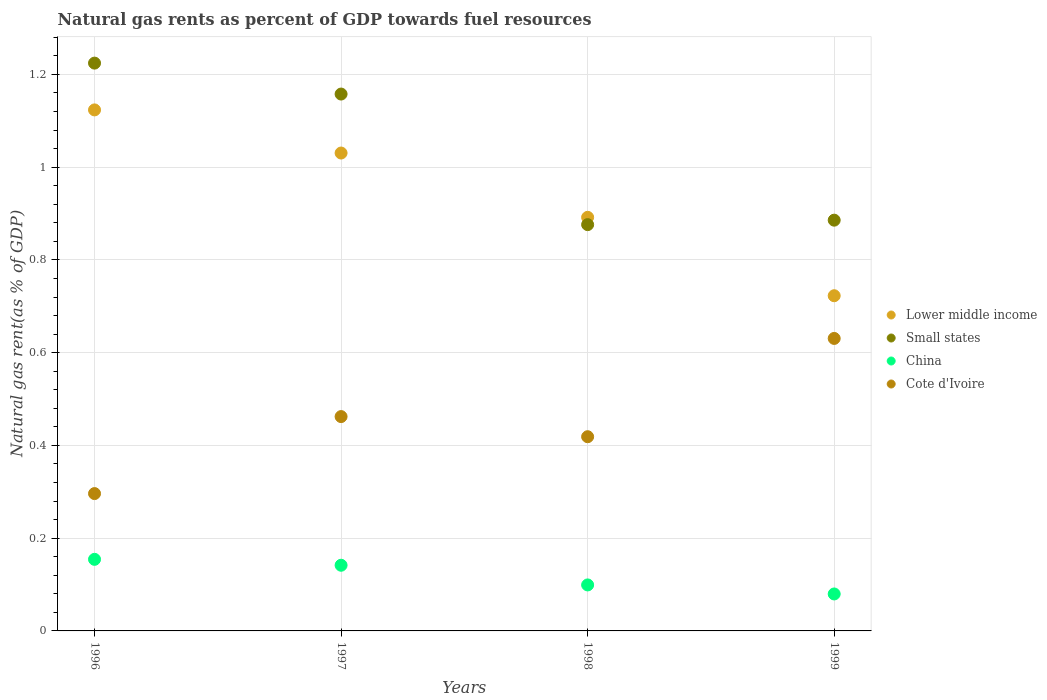Is the number of dotlines equal to the number of legend labels?
Your answer should be compact. Yes. What is the natural gas rent in Cote d'Ivoire in 1998?
Your answer should be very brief. 0.42. Across all years, what is the maximum natural gas rent in Small states?
Make the answer very short. 1.22. Across all years, what is the minimum natural gas rent in China?
Provide a succinct answer. 0.08. In which year was the natural gas rent in Lower middle income minimum?
Your response must be concise. 1999. What is the total natural gas rent in China in the graph?
Make the answer very short. 0.47. What is the difference between the natural gas rent in China in 1996 and that in 1999?
Offer a very short reply. 0.07. What is the difference between the natural gas rent in China in 1997 and the natural gas rent in Small states in 1999?
Offer a very short reply. -0.74. What is the average natural gas rent in Lower middle income per year?
Ensure brevity in your answer.  0.94. In the year 1999, what is the difference between the natural gas rent in Cote d'Ivoire and natural gas rent in Lower middle income?
Give a very brief answer. -0.09. In how many years, is the natural gas rent in Cote d'Ivoire greater than 0.7600000000000001 %?
Give a very brief answer. 0. What is the ratio of the natural gas rent in Small states in 1996 to that in 1997?
Your response must be concise. 1.06. Is the natural gas rent in Small states in 1997 less than that in 1999?
Keep it short and to the point. No. Is the difference between the natural gas rent in Cote d'Ivoire in 1996 and 1997 greater than the difference between the natural gas rent in Lower middle income in 1996 and 1997?
Provide a short and direct response. No. What is the difference between the highest and the second highest natural gas rent in China?
Keep it short and to the point. 0.01. What is the difference between the highest and the lowest natural gas rent in Cote d'Ivoire?
Ensure brevity in your answer.  0.33. In how many years, is the natural gas rent in Lower middle income greater than the average natural gas rent in Lower middle income taken over all years?
Provide a succinct answer. 2. Is the sum of the natural gas rent in Cote d'Ivoire in 1996 and 1999 greater than the maximum natural gas rent in Lower middle income across all years?
Provide a succinct answer. No. Is it the case that in every year, the sum of the natural gas rent in Lower middle income and natural gas rent in Small states  is greater than the sum of natural gas rent in Cote d'Ivoire and natural gas rent in China?
Give a very brief answer. No. Is it the case that in every year, the sum of the natural gas rent in Lower middle income and natural gas rent in Cote d'Ivoire  is greater than the natural gas rent in China?
Your answer should be compact. Yes. Does the natural gas rent in Lower middle income monotonically increase over the years?
Ensure brevity in your answer.  No. Is the natural gas rent in China strictly greater than the natural gas rent in Small states over the years?
Give a very brief answer. No. Is the natural gas rent in Small states strictly less than the natural gas rent in Cote d'Ivoire over the years?
Your answer should be very brief. No. How many dotlines are there?
Your answer should be very brief. 4. How many years are there in the graph?
Provide a short and direct response. 4. What is the difference between two consecutive major ticks on the Y-axis?
Ensure brevity in your answer.  0.2. Does the graph contain any zero values?
Provide a succinct answer. No. How many legend labels are there?
Your response must be concise. 4. What is the title of the graph?
Keep it short and to the point. Natural gas rents as percent of GDP towards fuel resources. Does "Brunei Darussalam" appear as one of the legend labels in the graph?
Your response must be concise. No. What is the label or title of the Y-axis?
Provide a succinct answer. Natural gas rent(as % of GDP). What is the Natural gas rent(as % of GDP) of Lower middle income in 1996?
Offer a very short reply. 1.12. What is the Natural gas rent(as % of GDP) of Small states in 1996?
Make the answer very short. 1.22. What is the Natural gas rent(as % of GDP) of China in 1996?
Ensure brevity in your answer.  0.15. What is the Natural gas rent(as % of GDP) of Cote d'Ivoire in 1996?
Provide a short and direct response. 0.3. What is the Natural gas rent(as % of GDP) of Lower middle income in 1997?
Your answer should be very brief. 1.03. What is the Natural gas rent(as % of GDP) in Small states in 1997?
Your answer should be very brief. 1.16. What is the Natural gas rent(as % of GDP) of China in 1997?
Offer a very short reply. 0.14. What is the Natural gas rent(as % of GDP) of Cote d'Ivoire in 1997?
Your response must be concise. 0.46. What is the Natural gas rent(as % of GDP) in Lower middle income in 1998?
Your answer should be very brief. 0.89. What is the Natural gas rent(as % of GDP) of Small states in 1998?
Provide a short and direct response. 0.88. What is the Natural gas rent(as % of GDP) of China in 1998?
Give a very brief answer. 0.1. What is the Natural gas rent(as % of GDP) in Cote d'Ivoire in 1998?
Your response must be concise. 0.42. What is the Natural gas rent(as % of GDP) in Lower middle income in 1999?
Offer a very short reply. 0.72. What is the Natural gas rent(as % of GDP) of Small states in 1999?
Provide a succinct answer. 0.89. What is the Natural gas rent(as % of GDP) of China in 1999?
Your response must be concise. 0.08. What is the Natural gas rent(as % of GDP) of Cote d'Ivoire in 1999?
Offer a terse response. 0.63. Across all years, what is the maximum Natural gas rent(as % of GDP) of Lower middle income?
Your answer should be very brief. 1.12. Across all years, what is the maximum Natural gas rent(as % of GDP) in Small states?
Provide a succinct answer. 1.22. Across all years, what is the maximum Natural gas rent(as % of GDP) in China?
Your answer should be compact. 0.15. Across all years, what is the maximum Natural gas rent(as % of GDP) of Cote d'Ivoire?
Ensure brevity in your answer.  0.63. Across all years, what is the minimum Natural gas rent(as % of GDP) in Lower middle income?
Your answer should be compact. 0.72. Across all years, what is the minimum Natural gas rent(as % of GDP) of Small states?
Make the answer very short. 0.88. Across all years, what is the minimum Natural gas rent(as % of GDP) of China?
Offer a very short reply. 0.08. Across all years, what is the minimum Natural gas rent(as % of GDP) in Cote d'Ivoire?
Keep it short and to the point. 0.3. What is the total Natural gas rent(as % of GDP) of Lower middle income in the graph?
Make the answer very short. 3.77. What is the total Natural gas rent(as % of GDP) in Small states in the graph?
Give a very brief answer. 4.14. What is the total Natural gas rent(as % of GDP) of China in the graph?
Offer a terse response. 0.47. What is the total Natural gas rent(as % of GDP) in Cote d'Ivoire in the graph?
Give a very brief answer. 1.81. What is the difference between the Natural gas rent(as % of GDP) of Lower middle income in 1996 and that in 1997?
Offer a terse response. 0.09. What is the difference between the Natural gas rent(as % of GDP) in Small states in 1996 and that in 1997?
Your answer should be very brief. 0.07. What is the difference between the Natural gas rent(as % of GDP) of China in 1996 and that in 1997?
Give a very brief answer. 0.01. What is the difference between the Natural gas rent(as % of GDP) of Cote d'Ivoire in 1996 and that in 1997?
Give a very brief answer. -0.17. What is the difference between the Natural gas rent(as % of GDP) of Lower middle income in 1996 and that in 1998?
Provide a short and direct response. 0.23. What is the difference between the Natural gas rent(as % of GDP) of Small states in 1996 and that in 1998?
Make the answer very short. 0.35. What is the difference between the Natural gas rent(as % of GDP) of China in 1996 and that in 1998?
Offer a terse response. 0.06. What is the difference between the Natural gas rent(as % of GDP) of Cote d'Ivoire in 1996 and that in 1998?
Make the answer very short. -0.12. What is the difference between the Natural gas rent(as % of GDP) of Lower middle income in 1996 and that in 1999?
Provide a short and direct response. 0.4. What is the difference between the Natural gas rent(as % of GDP) of Small states in 1996 and that in 1999?
Offer a very short reply. 0.34. What is the difference between the Natural gas rent(as % of GDP) of China in 1996 and that in 1999?
Ensure brevity in your answer.  0.07. What is the difference between the Natural gas rent(as % of GDP) of Cote d'Ivoire in 1996 and that in 1999?
Ensure brevity in your answer.  -0.33. What is the difference between the Natural gas rent(as % of GDP) of Lower middle income in 1997 and that in 1998?
Ensure brevity in your answer.  0.14. What is the difference between the Natural gas rent(as % of GDP) of Small states in 1997 and that in 1998?
Keep it short and to the point. 0.28. What is the difference between the Natural gas rent(as % of GDP) in China in 1997 and that in 1998?
Provide a short and direct response. 0.04. What is the difference between the Natural gas rent(as % of GDP) in Cote d'Ivoire in 1997 and that in 1998?
Your answer should be very brief. 0.04. What is the difference between the Natural gas rent(as % of GDP) in Lower middle income in 1997 and that in 1999?
Give a very brief answer. 0.31. What is the difference between the Natural gas rent(as % of GDP) of Small states in 1997 and that in 1999?
Ensure brevity in your answer.  0.27. What is the difference between the Natural gas rent(as % of GDP) in China in 1997 and that in 1999?
Your answer should be compact. 0.06. What is the difference between the Natural gas rent(as % of GDP) of Cote d'Ivoire in 1997 and that in 1999?
Your answer should be very brief. -0.17. What is the difference between the Natural gas rent(as % of GDP) in Lower middle income in 1998 and that in 1999?
Your response must be concise. 0.17. What is the difference between the Natural gas rent(as % of GDP) of Small states in 1998 and that in 1999?
Offer a very short reply. -0.01. What is the difference between the Natural gas rent(as % of GDP) in China in 1998 and that in 1999?
Your answer should be very brief. 0.02. What is the difference between the Natural gas rent(as % of GDP) in Cote d'Ivoire in 1998 and that in 1999?
Give a very brief answer. -0.21. What is the difference between the Natural gas rent(as % of GDP) of Lower middle income in 1996 and the Natural gas rent(as % of GDP) of Small states in 1997?
Your answer should be very brief. -0.03. What is the difference between the Natural gas rent(as % of GDP) of Lower middle income in 1996 and the Natural gas rent(as % of GDP) of China in 1997?
Give a very brief answer. 0.98. What is the difference between the Natural gas rent(as % of GDP) of Lower middle income in 1996 and the Natural gas rent(as % of GDP) of Cote d'Ivoire in 1997?
Your response must be concise. 0.66. What is the difference between the Natural gas rent(as % of GDP) of Small states in 1996 and the Natural gas rent(as % of GDP) of China in 1997?
Ensure brevity in your answer.  1.08. What is the difference between the Natural gas rent(as % of GDP) in Small states in 1996 and the Natural gas rent(as % of GDP) in Cote d'Ivoire in 1997?
Ensure brevity in your answer.  0.76. What is the difference between the Natural gas rent(as % of GDP) of China in 1996 and the Natural gas rent(as % of GDP) of Cote d'Ivoire in 1997?
Offer a very short reply. -0.31. What is the difference between the Natural gas rent(as % of GDP) in Lower middle income in 1996 and the Natural gas rent(as % of GDP) in Small states in 1998?
Keep it short and to the point. 0.25. What is the difference between the Natural gas rent(as % of GDP) of Lower middle income in 1996 and the Natural gas rent(as % of GDP) of China in 1998?
Your answer should be compact. 1.02. What is the difference between the Natural gas rent(as % of GDP) of Lower middle income in 1996 and the Natural gas rent(as % of GDP) of Cote d'Ivoire in 1998?
Ensure brevity in your answer.  0.7. What is the difference between the Natural gas rent(as % of GDP) of Small states in 1996 and the Natural gas rent(as % of GDP) of China in 1998?
Offer a very short reply. 1.13. What is the difference between the Natural gas rent(as % of GDP) of Small states in 1996 and the Natural gas rent(as % of GDP) of Cote d'Ivoire in 1998?
Make the answer very short. 0.81. What is the difference between the Natural gas rent(as % of GDP) in China in 1996 and the Natural gas rent(as % of GDP) in Cote d'Ivoire in 1998?
Provide a short and direct response. -0.26. What is the difference between the Natural gas rent(as % of GDP) of Lower middle income in 1996 and the Natural gas rent(as % of GDP) of Small states in 1999?
Provide a succinct answer. 0.24. What is the difference between the Natural gas rent(as % of GDP) in Lower middle income in 1996 and the Natural gas rent(as % of GDP) in China in 1999?
Offer a terse response. 1.04. What is the difference between the Natural gas rent(as % of GDP) in Lower middle income in 1996 and the Natural gas rent(as % of GDP) in Cote d'Ivoire in 1999?
Your response must be concise. 0.49. What is the difference between the Natural gas rent(as % of GDP) in Small states in 1996 and the Natural gas rent(as % of GDP) in China in 1999?
Make the answer very short. 1.14. What is the difference between the Natural gas rent(as % of GDP) in Small states in 1996 and the Natural gas rent(as % of GDP) in Cote d'Ivoire in 1999?
Your answer should be compact. 0.59. What is the difference between the Natural gas rent(as % of GDP) of China in 1996 and the Natural gas rent(as % of GDP) of Cote d'Ivoire in 1999?
Offer a terse response. -0.48. What is the difference between the Natural gas rent(as % of GDP) in Lower middle income in 1997 and the Natural gas rent(as % of GDP) in Small states in 1998?
Your response must be concise. 0.15. What is the difference between the Natural gas rent(as % of GDP) in Lower middle income in 1997 and the Natural gas rent(as % of GDP) in China in 1998?
Ensure brevity in your answer.  0.93. What is the difference between the Natural gas rent(as % of GDP) of Lower middle income in 1997 and the Natural gas rent(as % of GDP) of Cote d'Ivoire in 1998?
Your answer should be very brief. 0.61. What is the difference between the Natural gas rent(as % of GDP) in Small states in 1997 and the Natural gas rent(as % of GDP) in China in 1998?
Provide a short and direct response. 1.06. What is the difference between the Natural gas rent(as % of GDP) in Small states in 1997 and the Natural gas rent(as % of GDP) in Cote d'Ivoire in 1998?
Keep it short and to the point. 0.74. What is the difference between the Natural gas rent(as % of GDP) in China in 1997 and the Natural gas rent(as % of GDP) in Cote d'Ivoire in 1998?
Give a very brief answer. -0.28. What is the difference between the Natural gas rent(as % of GDP) in Lower middle income in 1997 and the Natural gas rent(as % of GDP) in Small states in 1999?
Give a very brief answer. 0.14. What is the difference between the Natural gas rent(as % of GDP) of Lower middle income in 1997 and the Natural gas rent(as % of GDP) of China in 1999?
Provide a short and direct response. 0.95. What is the difference between the Natural gas rent(as % of GDP) in Lower middle income in 1997 and the Natural gas rent(as % of GDP) in Cote d'Ivoire in 1999?
Give a very brief answer. 0.4. What is the difference between the Natural gas rent(as % of GDP) in Small states in 1997 and the Natural gas rent(as % of GDP) in China in 1999?
Ensure brevity in your answer.  1.08. What is the difference between the Natural gas rent(as % of GDP) of Small states in 1997 and the Natural gas rent(as % of GDP) of Cote d'Ivoire in 1999?
Make the answer very short. 0.53. What is the difference between the Natural gas rent(as % of GDP) in China in 1997 and the Natural gas rent(as % of GDP) in Cote d'Ivoire in 1999?
Offer a very short reply. -0.49. What is the difference between the Natural gas rent(as % of GDP) of Lower middle income in 1998 and the Natural gas rent(as % of GDP) of Small states in 1999?
Keep it short and to the point. 0.01. What is the difference between the Natural gas rent(as % of GDP) in Lower middle income in 1998 and the Natural gas rent(as % of GDP) in China in 1999?
Give a very brief answer. 0.81. What is the difference between the Natural gas rent(as % of GDP) in Lower middle income in 1998 and the Natural gas rent(as % of GDP) in Cote d'Ivoire in 1999?
Make the answer very short. 0.26. What is the difference between the Natural gas rent(as % of GDP) in Small states in 1998 and the Natural gas rent(as % of GDP) in China in 1999?
Provide a succinct answer. 0.8. What is the difference between the Natural gas rent(as % of GDP) in Small states in 1998 and the Natural gas rent(as % of GDP) in Cote d'Ivoire in 1999?
Keep it short and to the point. 0.25. What is the difference between the Natural gas rent(as % of GDP) of China in 1998 and the Natural gas rent(as % of GDP) of Cote d'Ivoire in 1999?
Give a very brief answer. -0.53. What is the average Natural gas rent(as % of GDP) of Lower middle income per year?
Ensure brevity in your answer.  0.94. What is the average Natural gas rent(as % of GDP) of Small states per year?
Provide a short and direct response. 1.04. What is the average Natural gas rent(as % of GDP) of China per year?
Your answer should be compact. 0.12. What is the average Natural gas rent(as % of GDP) of Cote d'Ivoire per year?
Ensure brevity in your answer.  0.45. In the year 1996, what is the difference between the Natural gas rent(as % of GDP) in Lower middle income and Natural gas rent(as % of GDP) in Small states?
Make the answer very short. -0.1. In the year 1996, what is the difference between the Natural gas rent(as % of GDP) of Lower middle income and Natural gas rent(as % of GDP) of China?
Your answer should be very brief. 0.97. In the year 1996, what is the difference between the Natural gas rent(as % of GDP) in Lower middle income and Natural gas rent(as % of GDP) in Cote d'Ivoire?
Your response must be concise. 0.83. In the year 1996, what is the difference between the Natural gas rent(as % of GDP) in Small states and Natural gas rent(as % of GDP) in China?
Your answer should be compact. 1.07. In the year 1996, what is the difference between the Natural gas rent(as % of GDP) of Small states and Natural gas rent(as % of GDP) of Cote d'Ivoire?
Make the answer very short. 0.93. In the year 1996, what is the difference between the Natural gas rent(as % of GDP) of China and Natural gas rent(as % of GDP) of Cote d'Ivoire?
Ensure brevity in your answer.  -0.14. In the year 1997, what is the difference between the Natural gas rent(as % of GDP) in Lower middle income and Natural gas rent(as % of GDP) in Small states?
Your answer should be compact. -0.13. In the year 1997, what is the difference between the Natural gas rent(as % of GDP) of Lower middle income and Natural gas rent(as % of GDP) of Cote d'Ivoire?
Offer a very short reply. 0.57. In the year 1997, what is the difference between the Natural gas rent(as % of GDP) in Small states and Natural gas rent(as % of GDP) in Cote d'Ivoire?
Your answer should be compact. 0.7. In the year 1997, what is the difference between the Natural gas rent(as % of GDP) in China and Natural gas rent(as % of GDP) in Cote d'Ivoire?
Provide a short and direct response. -0.32. In the year 1998, what is the difference between the Natural gas rent(as % of GDP) of Lower middle income and Natural gas rent(as % of GDP) of Small states?
Offer a terse response. 0.02. In the year 1998, what is the difference between the Natural gas rent(as % of GDP) of Lower middle income and Natural gas rent(as % of GDP) of China?
Ensure brevity in your answer.  0.79. In the year 1998, what is the difference between the Natural gas rent(as % of GDP) in Lower middle income and Natural gas rent(as % of GDP) in Cote d'Ivoire?
Offer a terse response. 0.47. In the year 1998, what is the difference between the Natural gas rent(as % of GDP) in Small states and Natural gas rent(as % of GDP) in China?
Offer a terse response. 0.78. In the year 1998, what is the difference between the Natural gas rent(as % of GDP) in Small states and Natural gas rent(as % of GDP) in Cote d'Ivoire?
Provide a succinct answer. 0.46. In the year 1998, what is the difference between the Natural gas rent(as % of GDP) in China and Natural gas rent(as % of GDP) in Cote d'Ivoire?
Ensure brevity in your answer.  -0.32. In the year 1999, what is the difference between the Natural gas rent(as % of GDP) in Lower middle income and Natural gas rent(as % of GDP) in Small states?
Your answer should be very brief. -0.16. In the year 1999, what is the difference between the Natural gas rent(as % of GDP) of Lower middle income and Natural gas rent(as % of GDP) of China?
Your answer should be compact. 0.64. In the year 1999, what is the difference between the Natural gas rent(as % of GDP) of Lower middle income and Natural gas rent(as % of GDP) of Cote d'Ivoire?
Your answer should be compact. 0.09. In the year 1999, what is the difference between the Natural gas rent(as % of GDP) of Small states and Natural gas rent(as % of GDP) of China?
Provide a short and direct response. 0.81. In the year 1999, what is the difference between the Natural gas rent(as % of GDP) of Small states and Natural gas rent(as % of GDP) of Cote d'Ivoire?
Your answer should be very brief. 0.26. In the year 1999, what is the difference between the Natural gas rent(as % of GDP) of China and Natural gas rent(as % of GDP) of Cote d'Ivoire?
Make the answer very short. -0.55. What is the ratio of the Natural gas rent(as % of GDP) in Lower middle income in 1996 to that in 1997?
Ensure brevity in your answer.  1.09. What is the ratio of the Natural gas rent(as % of GDP) of Small states in 1996 to that in 1997?
Provide a short and direct response. 1.06. What is the ratio of the Natural gas rent(as % of GDP) of China in 1996 to that in 1997?
Make the answer very short. 1.09. What is the ratio of the Natural gas rent(as % of GDP) of Cote d'Ivoire in 1996 to that in 1997?
Your answer should be very brief. 0.64. What is the ratio of the Natural gas rent(as % of GDP) in Lower middle income in 1996 to that in 1998?
Provide a succinct answer. 1.26. What is the ratio of the Natural gas rent(as % of GDP) in Small states in 1996 to that in 1998?
Ensure brevity in your answer.  1.4. What is the ratio of the Natural gas rent(as % of GDP) in China in 1996 to that in 1998?
Your answer should be compact. 1.56. What is the ratio of the Natural gas rent(as % of GDP) of Cote d'Ivoire in 1996 to that in 1998?
Your answer should be compact. 0.71. What is the ratio of the Natural gas rent(as % of GDP) in Lower middle income in 1996 to that in 1999?
Give a very brief answer. 1.55. What is the ratio of the Natural gas rent(as % of GDP) of Small states in 1996 to that in 1999?
Provide a succinct answer. 1.38. What is the ratio of the Natural gas rent(as % of GDP) of China in 1996 to that in 1999?
Offer a terse response. 1.94. What is the ratio of the Natural gas rent(as % of GDP) of Cote d'Ivoire in 1996 to that in 1999?
Provide a succinct answer. 0.47. What is the ratio of the Natural gas rent(as % of GDP) in Lower middle income in 1997 to that in 1998?
Your answer should be compact. 1.16. What is the ratio of the Natural gas rent(as % of GDP) of Small states in 1997 to that in 1998?
Your response must be concise. 1.32. What is the ratio of the Natural gas rent(as % of GDP) of China in 1997 to that in 1998?
Your answer should be very brief. 1.43. What is the ratio of the Natural gas rent(as % of GDP) in Cote d'Ivoire in 1997 to that in 1998?
Give a very brief answer. 1.1. What is the ratio of the Natural gas rent(as % of GDP) of Lower middle income in 1997 to that in 1999?
Offer a terse response. 1.43. What is the ratio of the Natural gas rent(as % of GDP) in Small states in 1997 to that in 1999?
Your answer should be very brief. 1.31. What is the ratio of the Natural gas rent(as % of GDP) in China in 1997 to that in 1999?
Your answer should be compact. 1.78. What is the ratio of the Natural gas rent(as % of GDP) in Cote d'Ivoire in 1997 to that in 1999?
Offer a terse response. 0.73. What is the ratio of the Natural gas rent(as % of GDP) of Lower middle income in 1998 to that in 1999?
Provide a succinct answer. 1.23. What is the ratio of the Natural gas rent(as % of GDP) in Small states in 1998 to that in 1999?
Offer a terse response. 0.99. What is the ratio of the Natural gas rent(as % of GDP) of China in 1998 to that in 1999?
Make the answer very short. 1.24. What is the ratio of the Natural gas rent(as % of GDP) of Cote d'Ivoire in 1998 to that in 1999?
Make the answer very short. 0.66. What is the difference between the highest and the second highest Natural gas rent(as % of GDP) of Lower middle income?
Offer a very short reply. 0.09. What is the difference between the highest and the second highest Natural gas rent(as % of GDP) in Small states?
Make the answer very short. 0.07. What is the difference between the highest and the second highest Natural gas rent(as % of GDP) in China?
Your answer should be very brief. 0.01. What is the difference between the highest and the second highest Natural gas rent(as % of GDP) in Cote d'Ivoire?
Ensure brevity in your answer.  0.17. What is the difference between the highest and the lowest Natural gas rent(as % of GDP) in Lower middle income?
Offer a very short reply. 0.4. What is the difference between the highest and the lowest Natural gas rent(as % of GDP) of Small states?
Your answer should be compact. 0.35. What is the difference between the highest and the lowest Natural gas rent(as % of GDP) in China?
Your answer should be compact. 0.07. What is the difference between the highest and the lowest Natural gas rent(as % of GDP) of Cote d'Ivoire?
Your answer should be very brief. 0.33. 